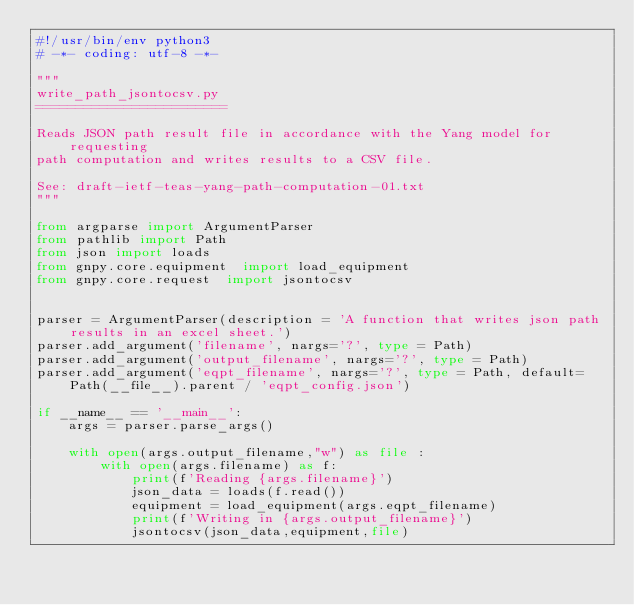<code> <loc_0><loc_0><loc_500><loc_500><_Python_>#!/usr/bin/env python3
# -*- coding: utf-8 -*-

"""
write_path_jsontocsv.py
========================

Reads JSON path result file in accordance with the Yang model for requesting
path computation and writes results to a CSV file.

See: draft-ietf-teas-yang-path-computation-01.txt
"""

from argparse import ArgumentParser
from pathlib import Path
from json import loads
from gnpy.core.equipment  import load_equipment
from gnpy.core.request  import jsontocsv


parser = ArgumentParser(description = 'A function that writes json path results in an excel sheet.')
parser.add_argument('filename', nargs='?', type = Path)
parser.add_argument('output_filename', nargs='?', type = Path)
parser.add_argument('eqpt_filename', nargs='?', type = Path, default=Path(__file__).parent / 'eqpt_config.json')

if __name__ == '__main__':
    args = parser.parse_args()

    with open(args.output_filename,"w") as file :
        with open(args.filename) as f:
            print(f'Reading {args.filename}')
            json_data = loads(f.read())
            equipment = load_equipment(args.eqpt_filename)
            print(f'Writing in {args.output_filename}')
            jsontocsv(json_data,equipment,file)

</code> 